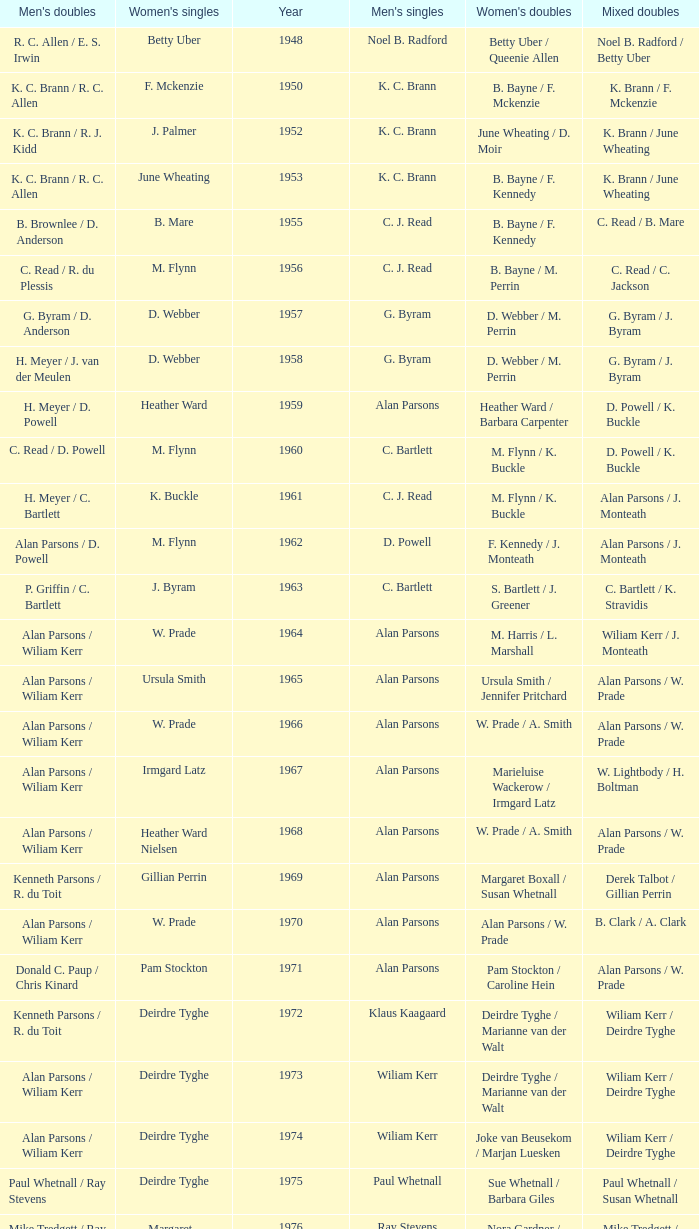Which Men's doubles have a Year smaller than 1960, and Men's singles of noel b. radford? R. C. Allen / E. S. Irwin. 